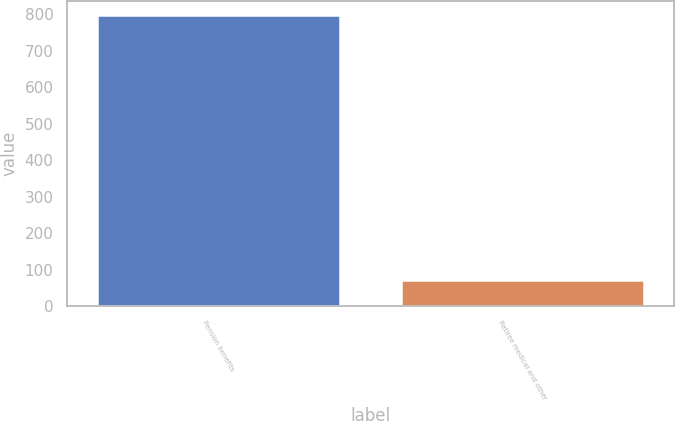Convert chart to OTSL. <chart><loc_0><loc_0><loc_500><loc_500><bar_chart><fcel>Pension benefits<fcel>Retiree medical and other<nl><fcel>797<fcel>71<nl></chart> 